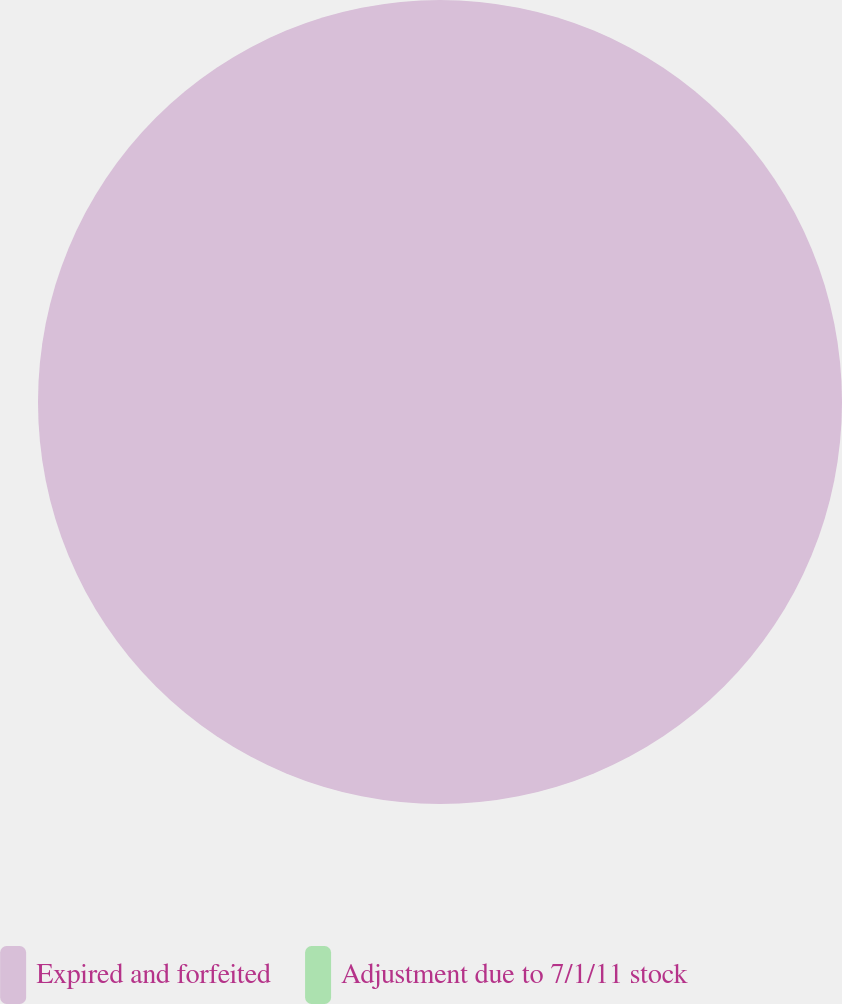Convert chart. <chart><loc_0><loc_0><loc_500><loc_500><pie_chart><fcel>Expired and forfeited<fcel>Adjustment due to 7/1/11 stock<nl><fcel>100.0%<fcel>0.0%<nl></chart> 